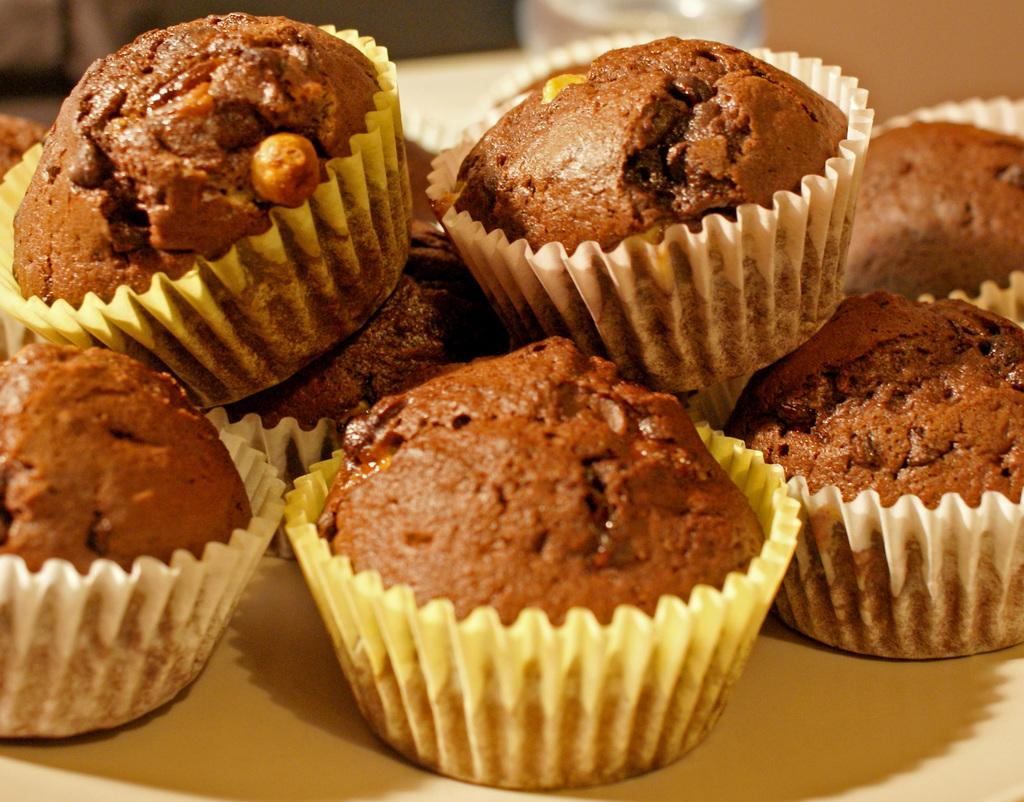What type of food can be seen in the image? There are cakes in the image. How many cows are grazing in the bushes near the cakes in the image? There are no cows or bushes present in the image; it only features cakes. 